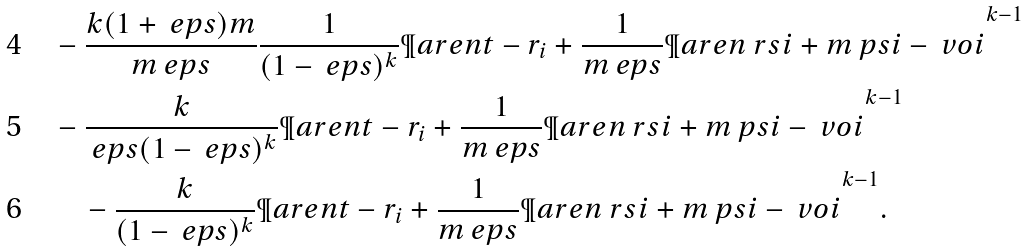Convert formula to latex. <formula><loc_0><loc_0><loc_500><loc_500>& - \frac { k ( 1 + \ e p s ) m } { m \ e p s } \frac { 1 } { ( 1 - \ e p s ) ^ { k } } \P a r e n { t - r _ { i } + \frac { 1 } { m \ e p s } \P a r e n { \ r s { i } + m \ p s { i } - \ v o { i } } } ^ { k - 1 } \\ & - \frac { k } { \ e p s ( 1 - \ e p s ) ^ { k } } \P a r e n { t - r _ { i } + \frac { 1 } { m \ e p s } \P a r e n { \ r s { i } + m \ p s { i } - \ v o { i } } } ^ { k - 1 } \\ & \quad - \frac { k } { ( 1 - \ e p s ) ^ { k } } \P a r e n { t - r _ { i } + \frac { 1 } { m \ e p s } \P a r e n { \ r s { i } + m \ p s { i } - \ v o { i } } } ^ { k - 1 } .</formula> 